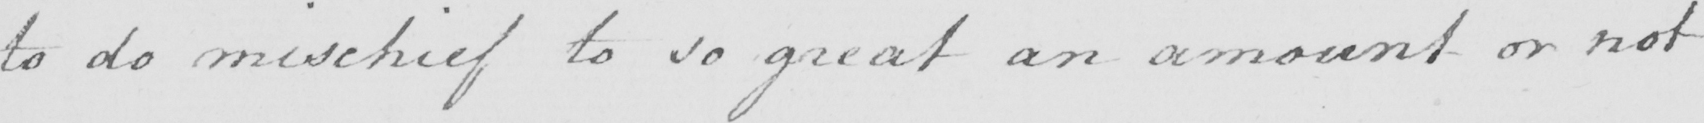Can you tell me what this handwritten text says? to do mischief to so great an amount or not 